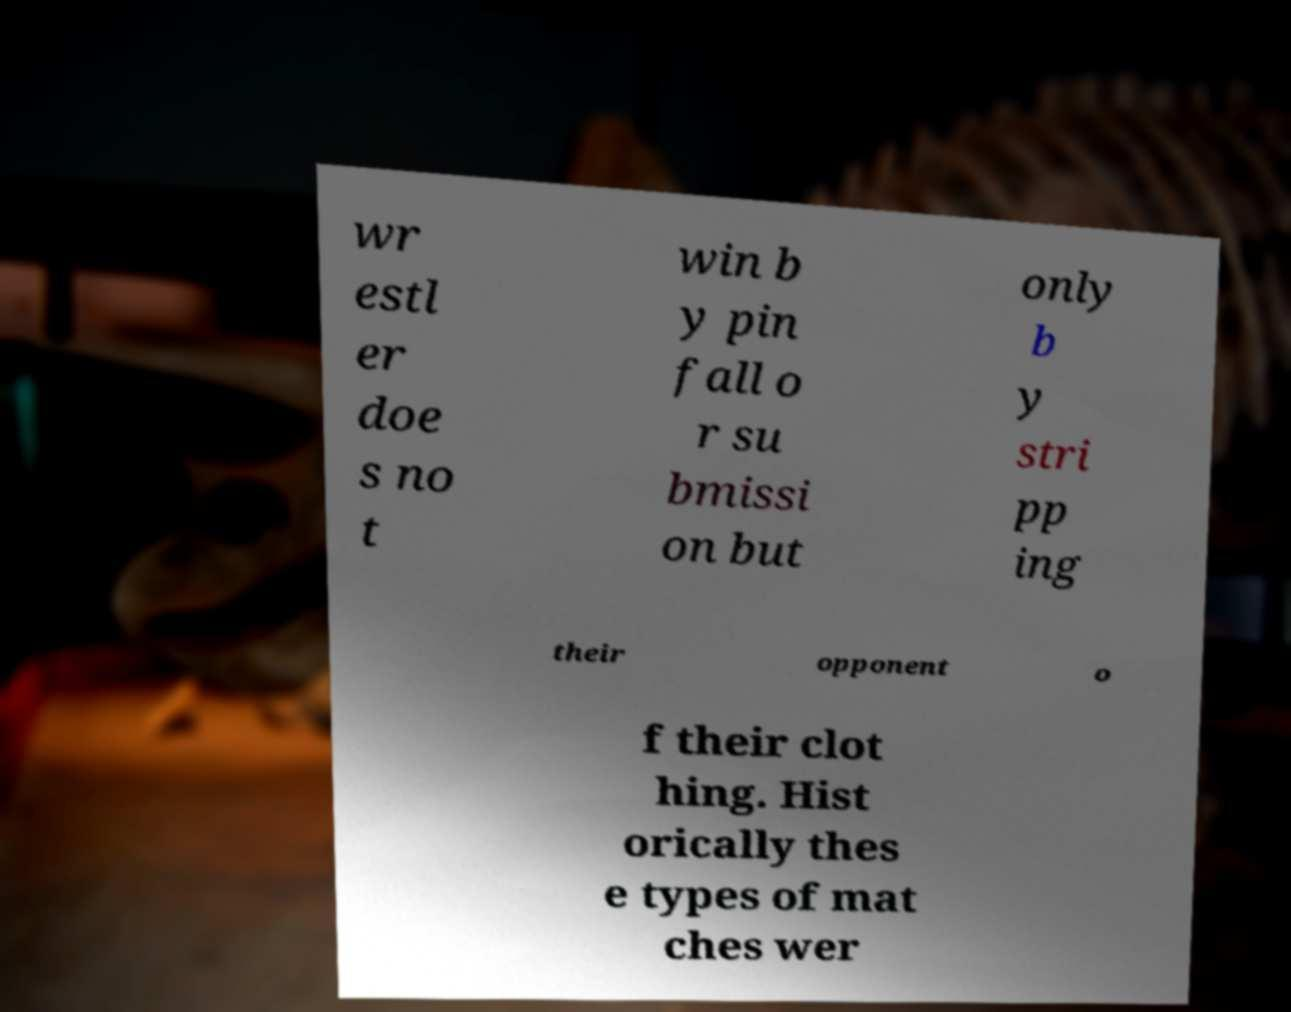For documentation purposes, I need the text within this image transcribed. Could you provide that? wr estl er doe s no t win b y pin fall o r su bmissi on but only b y stri pp ing their opponent o f their clot hing. Hist orically thes e types of mat ches wer 